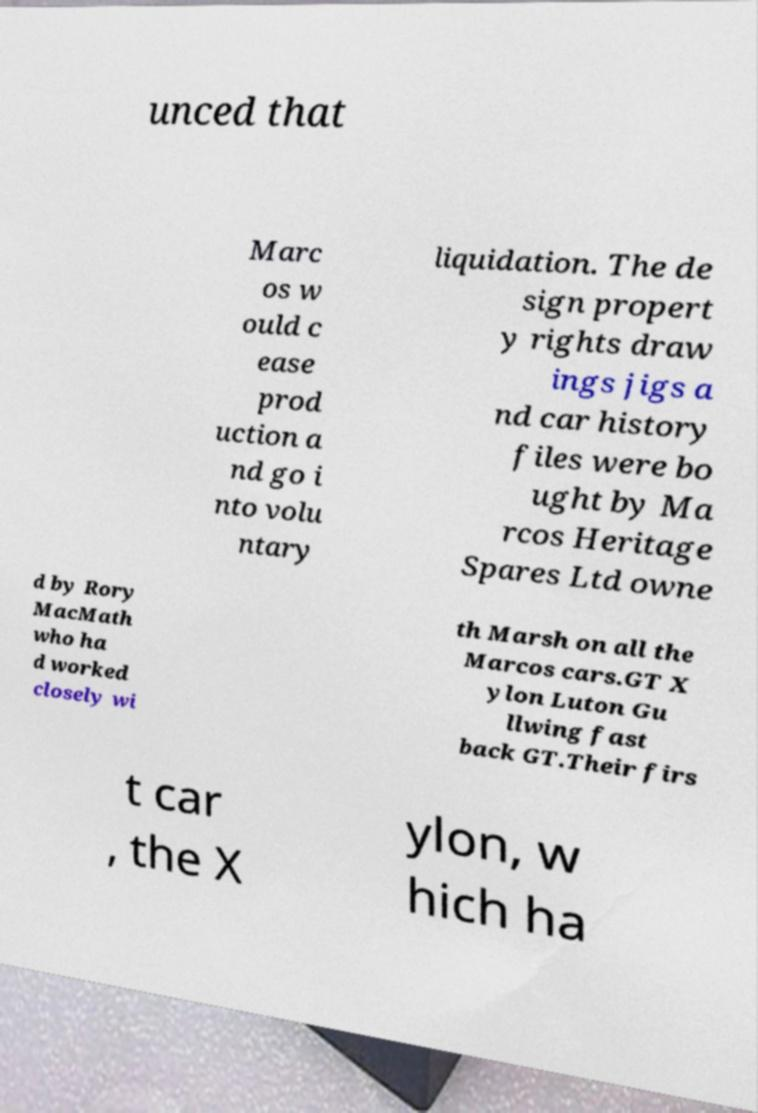I need the written content from this picture converted into text. Can you do that? unced that Marc os w ould c ease prod uction a nd go i nto volu ntary liquidation. The de sign propert y rights draw ings jigs a nd car history files were bo ught by Ma rcos Heritage Spares Ltd owne d by Rory MacMath who ha d worked closely wi th Marsh on all the Marcos cars.GT X ylon Luton Gu llwing fast back GT.Their firs t car , the X ylon, w hich ha 